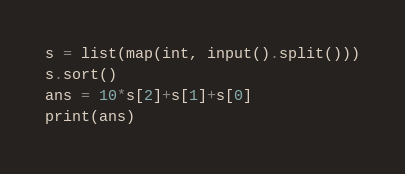Convert code to text. <code><loc_0><loc_0><loc_500><loc_500><_Python_>s = list(map(int, input().split()))
s.sort()
ans = 10*s[2]+s[1]+s[0]
print(ans)</code> 